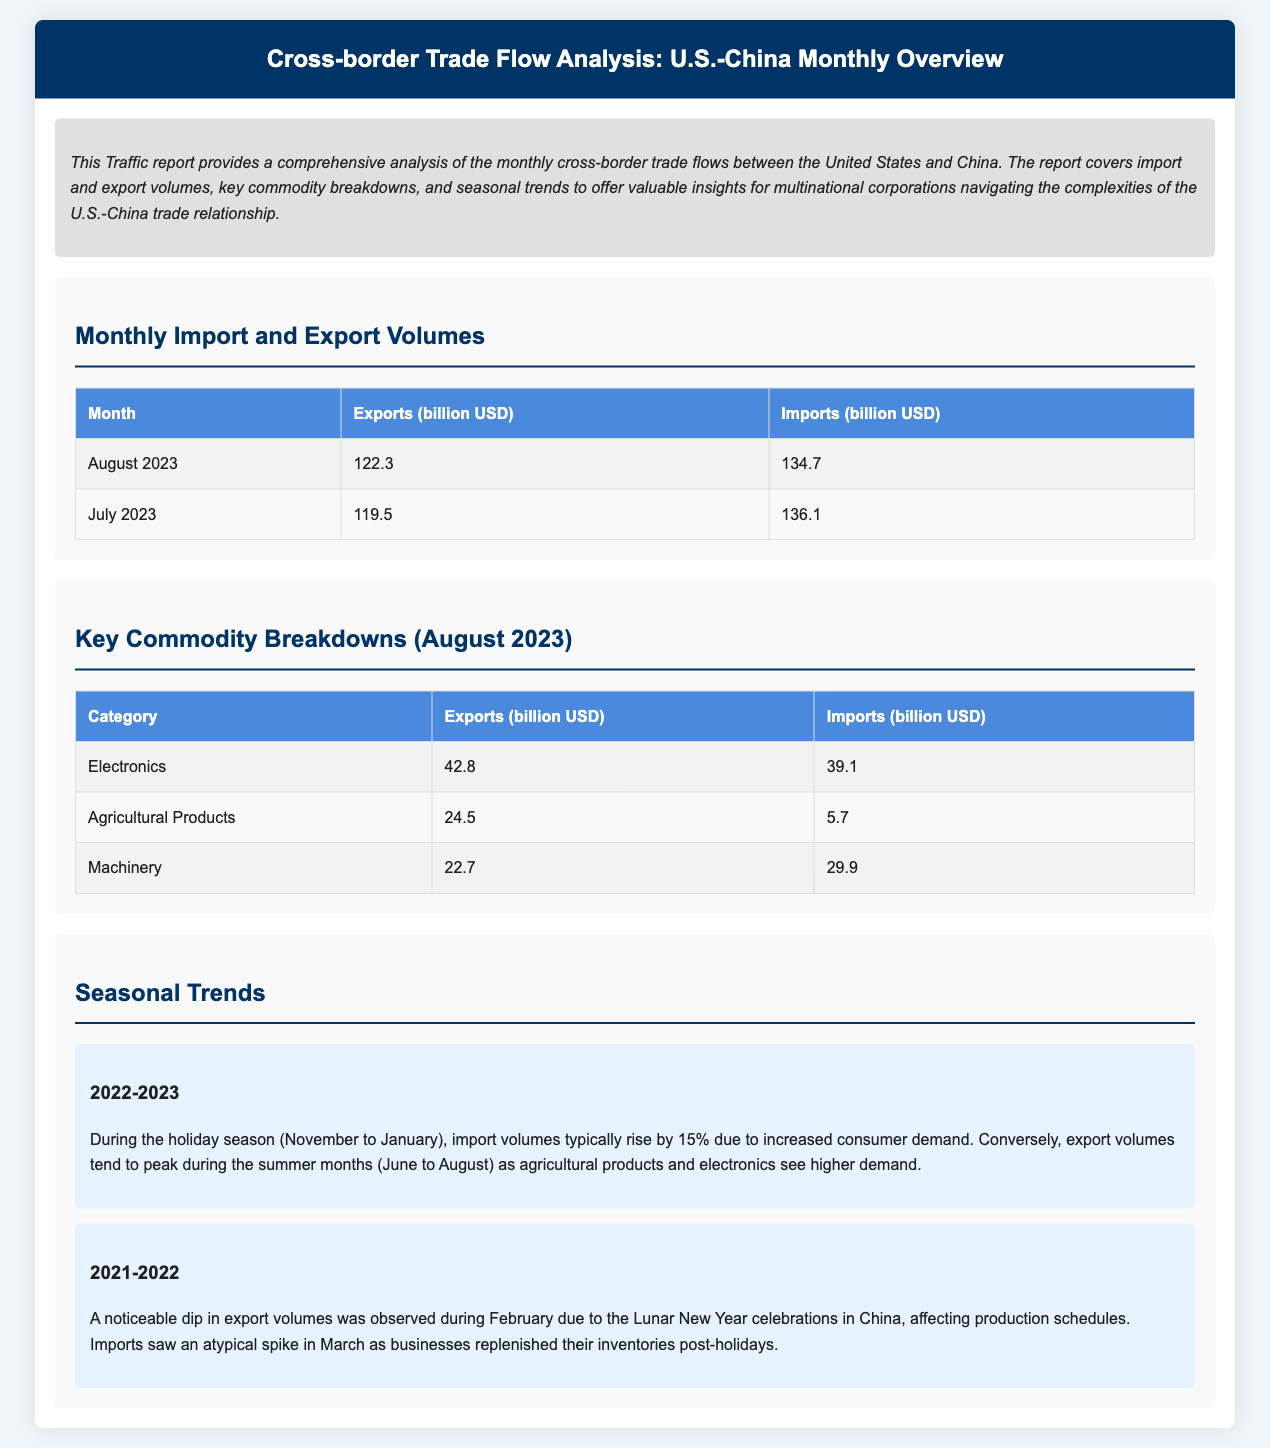What were the total exports from the U.S. in August 2023? The exports in August 2023 were listed as 122.3 billion USD.
Answer: 122.3 billion USD What were the total imports from China in July 2023? The imports from China in July 2023 were stated as 136.1 billion USD.
Answer: 136.1 billion USD Which commodity had the highest exports in August 2023? The category with the highest exports in August 2023 is Electronics, at 42.8 billion USD.
Answer: Electronics What percentage increase in imports is expected during the holiday season? The report mentions a typical rise of 15% in import volumes during the holiday season.
Answer: 15% What trend was observed in export volumes during February 2022? A noticeable dip in export volumes was observed in February due to the Lunar New Year celebrations in China.
Answer: Dip Which month typically sees peak export volumes due to higher demand for agricultural products? The document highlights June to August as peak export months, specifically during summer.
Answer: June to August What was the import volume for Machinery in August 2023? The import volume for Machinery in August 2023 was 29.9 billion USD.
Answer: 29.9 billion USD What seasonal effect did March have on imports in 2022? March experienced an atypical spike in imports as businesses replenished their inventories post-holidays.
Answer: Atypical spike What is the main focus of this Traffic report? The report provides a comprehensive analysis of monthly cross-border trade flows between the U.S. and China.
Answer: Monthly cross-border trade flows 